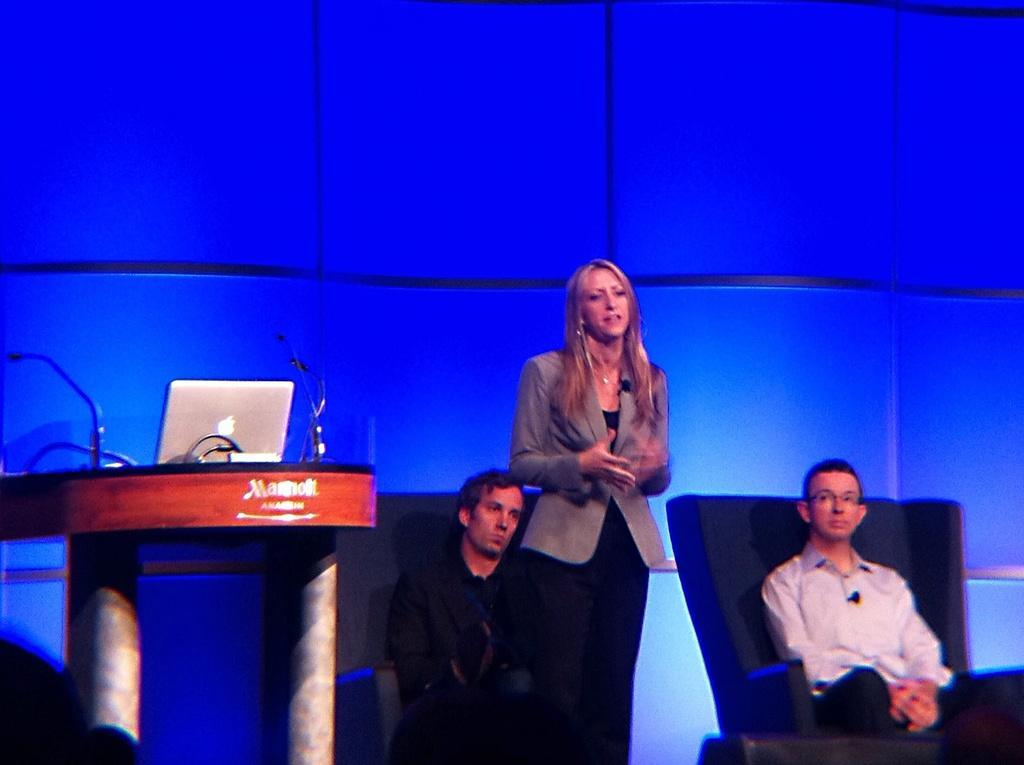Could you give a brief overview of what you see in this image? In the center of the image there is a woman standing on the dais. On the right side of the image we can see person sitting on the chair. On the left side of the image we can see laptops and mics placed on the desk. In the background we can see persons and wall. 